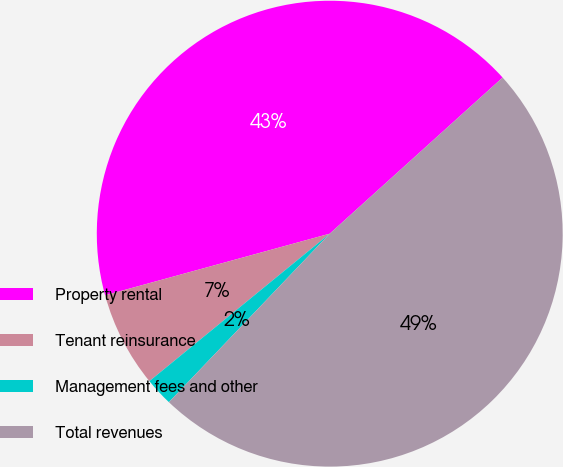Convert chart to OTSL. <chart><loc_0><loc_0><loc_500><loc_500><pie_chart><fcel>Property rental<fcel>Tenant reinsurance<fcel>Management fees and other<fcel>Total revenues<nl><fcel>42.57%<fcel>6.65%<fcel>1.96%<fcel>48.82%<nl></chart> 